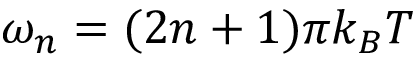<formula> <loc_0><loc_0><loc_500><loc_500>\omega _ { n } = ( 2 n + 1 ) \pi k _ { B } T</formula> 